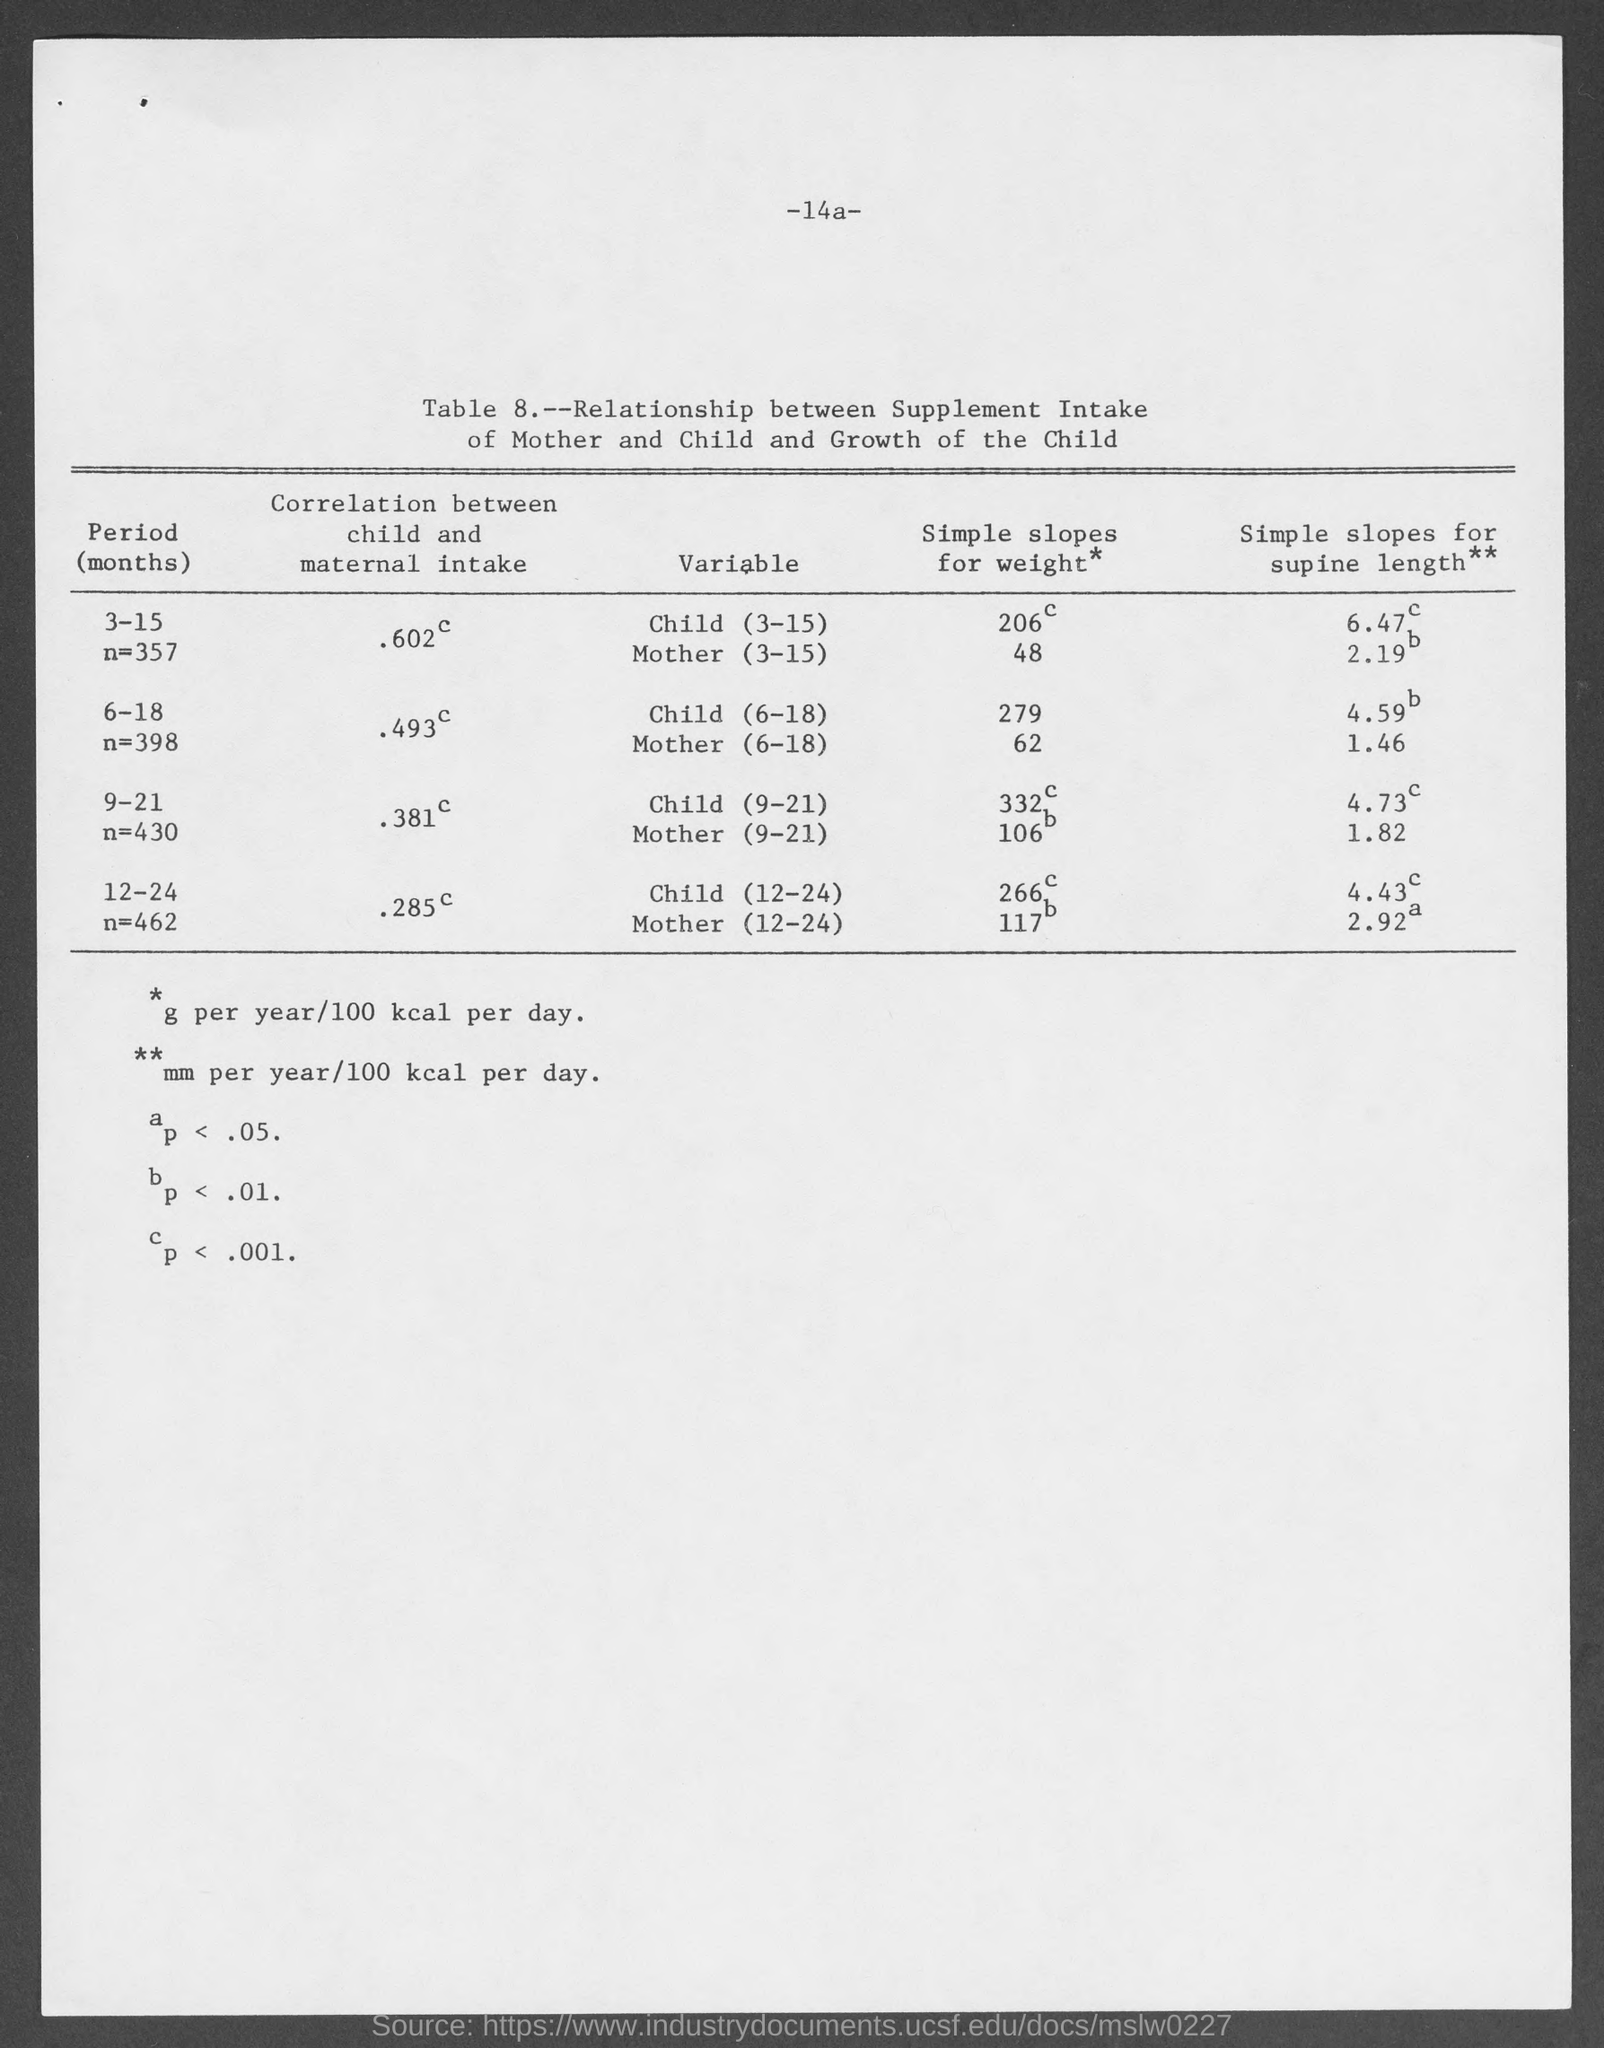Give some essential details in this illustration. I would like to know the table number. Could you please tell me which table is number 8? 